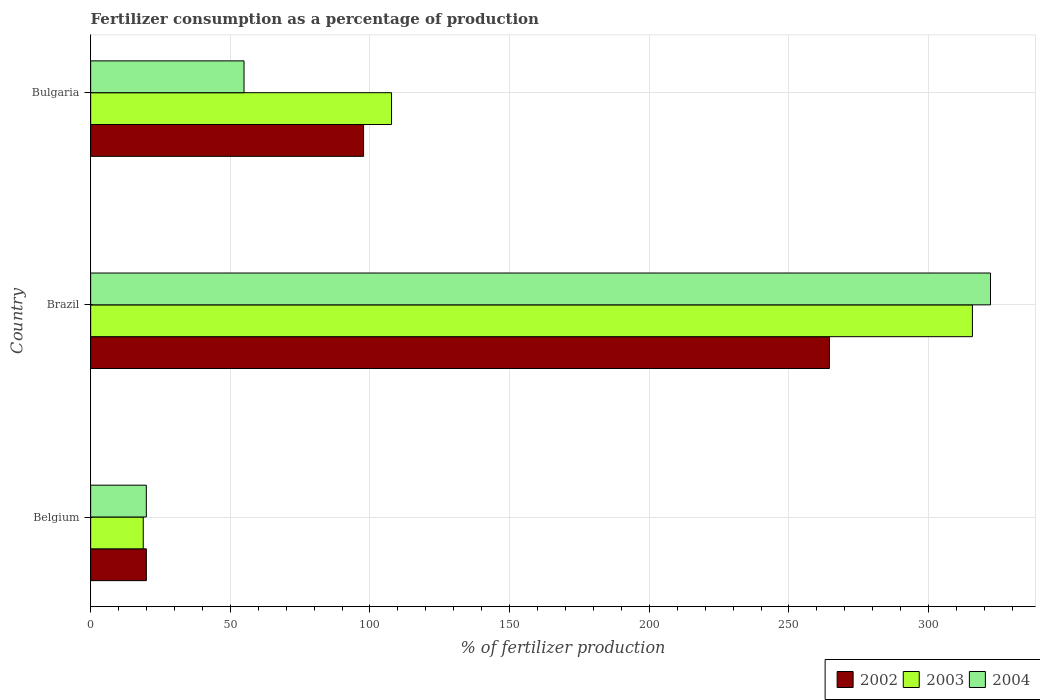How many groups of bars are there?
Your answer should be compact. 3. Are the number of bars on each tick of the Y-axis equal?
Your answer should be compact. Yes. How many bars are there on the 1st tick from the top?
Keep it short and to the point. 3. In how many cases, is the number of bars for a given country not equal to the number of legend labels?
Your answer should be compact. 0. What is the percentage of fertilizers consumed in 2004 in Bulgaria?
Provide a short and direct response. 54.91. Across all countries, what is the maximum percentage of fertilizers consumed in 2003?
Your answer should be compact. 315.68. Across all countries, what is the minimum percentage of fertilizers consumed in 2003?
Your answer should be compact. 18.83. In which country was the percentage of fertilizers consumed in 2003 minimum?
Offer a very short reply. Belgium. What is the total percentage of fertilizers consumed in 2003 in the graph?
Your answer should be compact. 442.23. What is the difference between the percentage of fertilizers consumed in 2002 in Belgium and that in Bulgaria?
Make the answer very short. -77.77. What is the difference between the percentage of fertilizers consumed in 2003 in Brazil and the percentage of fertilizers consumed in 2004 in Bulgaria?
Make the answer very short. 260.77. What is the average percentage of fertilizers consumed in 2003 per country?
Keep it short and to the point. 147.41. What is the difference between the percentage of fertilizers consumed in 2004 and percentage of fertilizers consumed in 2002 in Brazil?
Offer a very short reply. 57.67. In how many countries, is the percentage of fertilizers consumed in 2003 greater than 260 %?
Give a very brief answer. 1. What is the ratio of the percentage of fertilizers consumed in 2003 in Belgium to that in Bulgaria?
Provide a succinct answer. 0.17. Is the difference between the percentage of fertilizers consumed in 2004 in Belgium and Bulgaria greater than the difference between the percentage of fertilizers consumed in 2002 in Belgium and Bulgaria?
Offer a terse response. Yes. What is the difference between the highest and the second highest percentage of fertilizers consumed in 2004?
Your response must be concise. 267.25. What is the difference between the highest and the lowest percentage of fertilizers consumed in 2004?
Your answer should be very brief. 302.23. Is the sum of the percentage of fertilizers consumed in 2004 in Brazil and Bulgaria greater than the maximum percentage of fertilizers consumed in 2003 across all countries?
Your answer should be compact. Yes. What does the 3rd bar from the top in Bulgaria represents?
Your response must be concise. 2002. What does the 3rd bar from the bottom in Bulgaria represents?
Offer a terse response. 2004. Is it the case that in every country, the sum of the percentage of fertilizers consumed in 2003 and percentage of fertilizers consumed in 2004 is greater than the percentage of fertilizers consumed in 2002?
Your answer should be compact. Yes. What is the difference between two consecutive major ticks on the X-axis?
Provide a short and direct response. 50. Are the values on the major ticks of X-axis written in scientific E-notation?
Your answer should be compact. No. Does the graph contain any zero values?
Keep it short and to the point. No. Does the graph contain grids?
Ensure brevity in your answer.  Yes. How many legend labels are there?
Your response must be concise. 3. How are the legend labels stacked?
Provide a short and direct response. Horizontal. What is the title of the graph?
Offer a very short reply. Fertilizer consumption as a percentage of production. What is the label or title of the X-axis?
Provide a short and direct response. % of fertilizer production. What is the % of fertilizer production of 2002 in Belgium?
Your answer should be very brief. 19.94. What is the % of fertilizer production of 2003 in Belgium?
Your response must be concise. 18.83. What is the % of fertilizer production in 2004 in Belgium?
Your answer should be very brief. 19.93. What is the % of fertilizer production of 2002 in Brazil?
Provide a short and direct response. 264.49. What is the % of fertilizer production in 2003 in Brazil?
Your answer should be compact. 315.68. What is the % of fertilizer production of 2004 in Brazil?
Make the answer very short. 322.16. What is the % of fertilizer production of 2002 in Bulgaria?
Make the answer very short. 97.71. What is the % of fertilizer production in 2003 in Bulgaria?
Ensure brevity in your answer.  107.72. What is the % of fertilizer production in 2004 in Bulgaria?
Your answer should be very brief. 54.91. Across all countries, what is the maximum % of fertilizer production of 2002?
Ensure brevity in your answer.  264.49. Across all countries, what is the maximum % of fertilizer production in 2003?
Provide a short and direct response. 315.68. Across all countries, what is the maximum % of fertilizer production in 2004?
Ensure brevity in your answer.  322.16. Across all countries, what is the minimum % of fertilizer production in 2002?
Provide a succinct answer. 19.94. Across all countries, what is the minimum % of fertilizer production in 2003?
Provide a succinct answer. 18.83. Across all countries, what is the minimum % of fertilizer production in 2004?
Offer a terse response. 19.93. What is the total % of fertilizer production in 2002 in the graph?
Provide a short and direct response. 382.14. What is the total % of fertilizer production in 2003 in the graph?
Offer a terse response. 442.23. What is the total % of fertilizer production in 2004 in the graph?
Your response must be concise. 397. What is the difference between the % of fertilizer production of 2002 in Belgium and that in Brazil?
Make the answer very short. -244.55. What is the difference between the % of fertilizer production in 2003 in Belgium and that in Brazil?
Give a very brief answer. -296.85. What is the difference between the % of fertilizer production in 2004 in Belgium and that in Brazil?
Ensure brevity in your answer.  -302.23. What is the difference between the % of fertilizer production of 2002 in Belgium and that in Bulgaria?
Your answer should be very brief. -77.77. What is the difference between the % of fertilizer production of 2003 in Belgium and that in Bulgaria?
Ensure brevity in your answer.  -88.89. What is the difference between the % of fertilizer production of 2004 in Belgium and that in Bulgaria?
Your response must be concise. -34.98. What is the difference between the % of fertilizer production in 2002 in Brazil and that in Bulgaria?
Your answer should be compact. 166.78. What is the difference between the % of fertilizer production of 2003 in Brazil and that in Bulgaria?
Offer a very short reply. 207.97. What is the difference between the % of fertilizer production of 2004 in Brazil and that in Bulgaria?
Your response must be concise. 267.25. What is the difference between the % of fertilizer production of 2002 in Belgium and the % of fertilizer production of 2003 in Brazil?
Your answer should be compact. -295.74. What is the difference between the % of fertilizer production of 2002 in Belgium and the % of fertilizer production of 2004 in Brazil?
Keep it short and to the point. -302.22. What is the difference between the % of fertilizer production in 2003 in Belgium and the % of fertilizer production in 2004 in Brazil?
Your answer should be compact. -303.33. What is the difference between the % of fertilizer production in 2002 in Belgium and the % of fertilizer production in 2003 in Bulgaria?
Keep it short and to the point. -87.78. What is the difference between the % of fertilizer production in 2002 in Belgium and the % of fertilizer production in 2004 in Bulgaria?
Provide a short and direct response. -34.97. What is the difference between the % of fertilizer production of 2003 in Belgium and the % of fertilizer production of 2004 in Bulgaria?
Keep it short and to the point. -36.08. What is the difference between the % of fertilizer production in 2002 in Brazil and the % of fertilizer production in 2003 in Bulgaria?
Your answer should be very brief. 156.77. What is the difference between the % of fertilizer production of 2002 in Brazil and the % of fertilizer production of 2004 in Bulgaria?
Provide a short and direct response. 209.58. What is the difference between the % of fertilizer production of 2003 in Brazil and the % of fertilizer production of 2004 in Bulgaria?
Keep it short and to the point. 260.77. What is the average % of fertilizer production in 2002 per country?
Your answer should be compact. 127.38. What is the average % of fertilizer production of 2003 per country?
Keep it short and to the point. 147.41. What is the average % of fertilizer production in 2004 per country?
Provide a succinct answer. 132.33. What is the difference between the % of fertilizer production of 2002 and % of fertilizer production of 2003 in Belgium?
Your answer should be compact. 1.11. What is the difference between the % of fertilizer production of 2002 and % of fertilizer production of 2004 in Belgium?
Provide a succinct answer. 0.01. What is the difference between the % of fertilizer production of 2003 and % of fertilizer production of 2004 in Belgium?
Ensure brevity in your answer.  -1.1. What is the difference between the % of fertilizer production in 2002 and % of fertilizer production in 2003 in Brazil?
Make the answer very short. -51.19. What is the difference between the % of fertilizer production of 2002 and % of fertilizer production of 2004 in Brazil?
Offer a terse response. -57.67. What is the difference between the % of fertilizer production of 2003 and % of fertilizer production of 2004 in Brazil?
Give a very brief answer. -6.47. What is the difference between the % of fertilizer production in 2002 and % of fertilizer production in 2003 in Bulgaria?
Provide a short and direct response. -10.01. What is the difference between the % of fertilizer production in 2002 and % of fertilizer production in 2004 in Bulgaria?
Ensure brevity in your answer.  42.8. What is the difference between the % of fertilizer production in 2003 and % of fertilizer production in 2004 in Bulgaria?
Your answer should be very brief. 52.8. What is the ratio of the % of fertilizer production in 2002 in Belgium to that in Brazil?
Your response must be concise. 0.08. What is the ratio of the % of fertilizer production of 2003 in Belgium to that in Brazil?
Your answer should be very brief. 0.06. What is the ratio of the % of fertilizer production of 2004 in Belgium to that in Brazil?
Make the answer very short. 0.06. What is the ratio of the % of fertilizer production in 2002 in Belgium to that in Bulgaria?
Keep it short and to the point. 0.2. What is the ratio of the % of fertilizer production of 2003 in Belgium to that in Bulgaria?
Your answer should be very brief. 0.17. What is the ratio of the % of fertilizer production of 2004 in Belgium to that in Bulgaria?
Provide a short and direct response. 0.36. What is the ratio of the % of fertilizer production in 2002 in Brazil to that in Bulgaria?
Offer a very short reply. 2.71. What is the ratio of the % of fertilizer production of 2003 in Brazil to that in Bulgaria?
Your response must be concise. 2.93. What is the ratio of the % of fertilizer production in 2004 in Brazil to that in Bulgaria?
Your answer should be very brief. 5.87. What is the difference between the highest and the second highest % of fertilizer production in 2002?
Offer a very short reply. 166.78. What is the difference between the highest and the second highest % of fertilizer production of 2003?
Make the answer very short. 207.97. What is the difference between the highest and the second highest % of fertilizer production of 2004?
Your response must be concise. 267.25. What is the difference between the highest and the lowest % of fertilizer production in 2002?
Keep it short and to the point. 244.55. What is the difference between the highest and the lowest % of fertilizer production in 2003?
Your response must be concise. 296.85. What is the difference between the highest and the lowest % of fertilizer production in 2004?
Your response must be concise. 302.23. 